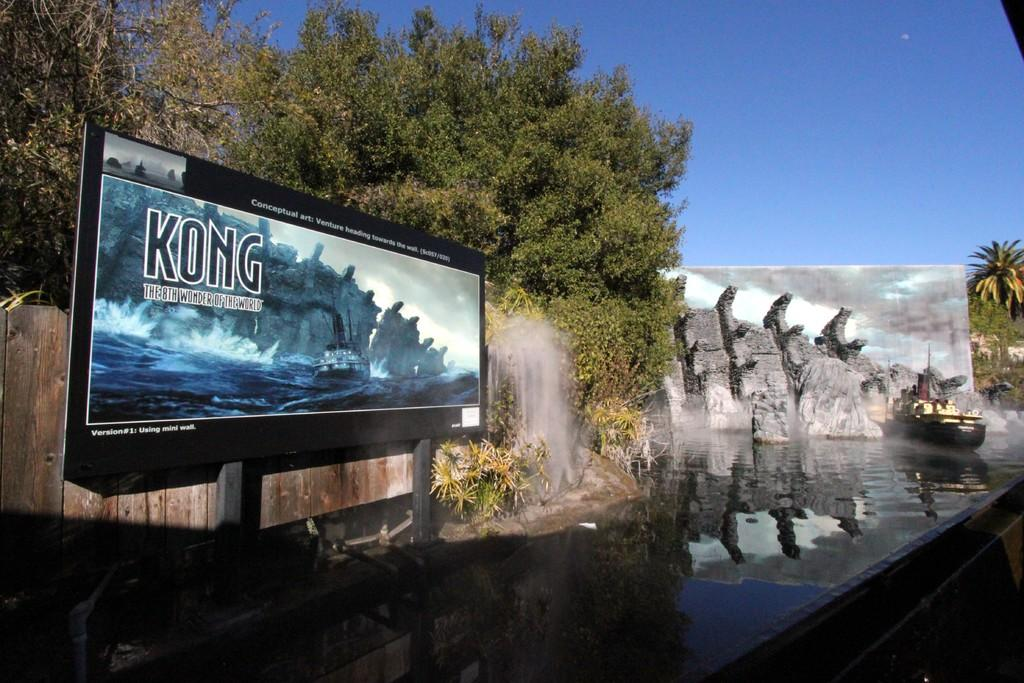<image>
Provide a brief description of the given image. A screen has the title Kong on it and trees can be seen behind. 